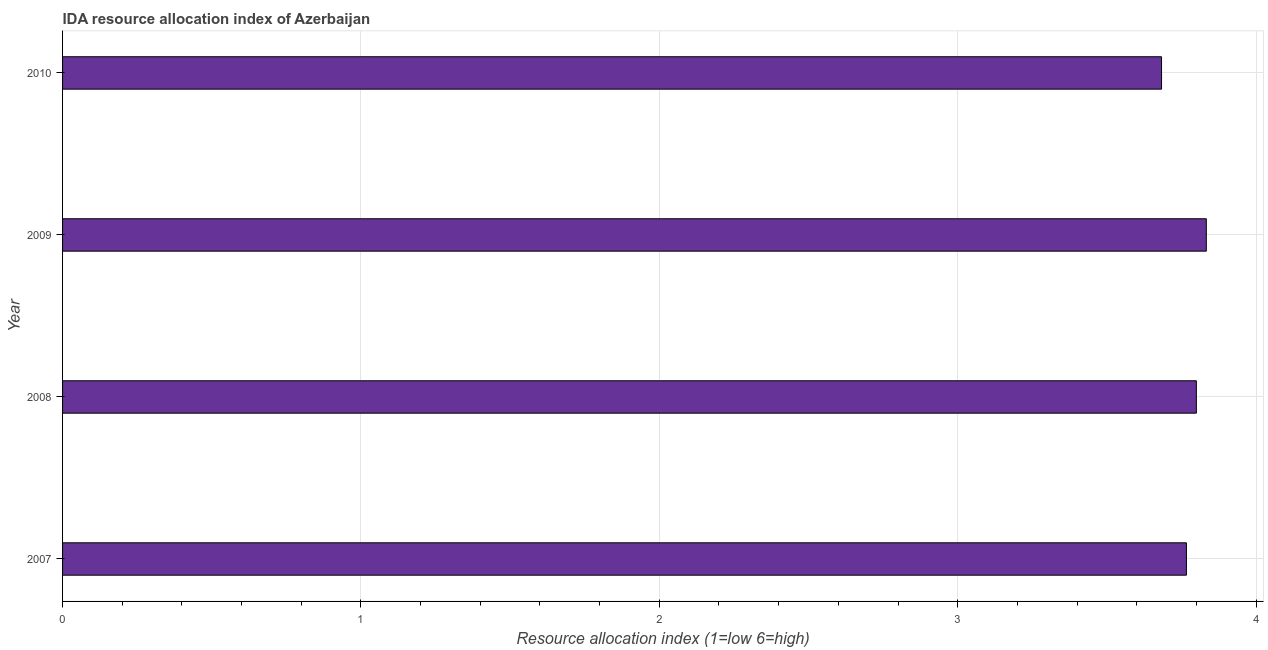Does the graph contain any zero values?
Make the answer very short. No. Does the graph contain grids?
Provide a succinct answer. Yes. What is the title of the graph?
Keep it short and to the point. IDA resource allocation index of Azerbaijan. What is the label or title of the X-axis?
Make the answer very short. Resource allocation index (1=low 6=high). What is the label or title of the Y-axis?
Make the answer very short. Year. What is the ida resource allocation index in 2007?
Offer a very short reply. 3.77. Across all years, what is the maximum ida resource allocation index?
Offer a terse response. 3.83. Across all years, what is the minimum ida resource allocation index?
Make the answer very short. 3.68. What is the sum of the ida resource allocation index?
Offer a terse response. 15.08. What is the average ida resource allocation index per year?
Your answer should be compact. 3.77. What is the median ida resource allocation index?
Your answer should be compact. 3.78. Do a majority of the years between 2008 and 2007 (inclusive) have ida resource allocation index greater than 3.8 ?
Give a very brief answer. No. What is the difference between the highest and the second highest ida resource allocation index?
Your response must be concise. 0.03. In how many years, is the ida resource allocation index greater than the average ida resource allocation index taken over all years?
Offer a terse response. 2. How many bars are there?
Make the answer very short. 4. Are all the bars in the graph horizontal?
Provide a short and direct response. Yes. Are the values on the major ticks of X-axis written in scientific E-notation?
Make the answer very short. No. What is the Resource allocation index (1=low 6=high) of 2007?
Your answer should be very brief. 3.77. What is the Resource allocation index (1=low 6=high) in 2009?
Offer a terse response. 3.83. What is the Resource allocation index (1=low 6=high) of 2010?
Keep it short and to the point. 3.68. What is the difference between the Resource allocation index (1=low 6=high) in 2007 and 2008?
Offer a terse response. -0.03. What is the difference between the Resource allocation index (1=low 6=high) in 2007 and 2009?
Your response must be concise. -0.07. What is the difference between the Resource allocation index (1=low 6=high) in 2007 and 2010?
Give a very brief answer. 0.08. What is the difference between the Resource allocation index (1=low 6=high) in 2008 and 2009?
Your answer should be very brief. -0.03. What is the difference between the Resource allocation index (1=low 6=high) in 2008 and 2010?
Offer a terse response. 0.12. What is the difference between the Resource allocation index (1=low 6=high) in 2009 and 2010?
Offer a very short reply. 0.15. What is the ratio of the Resource allocation index (1=low 6=high) in 2008 to that in 2009?
Offer a terse response. 0.99. What is the ratio of the Resource allocation index (1=low 6=high) in 2008 to that in 2010?
Keep it short and to the point. 1.03. What is the ratio of the Resource allocation index (1=low 6=high) in 2009 to that in 2010?
Give a very brief answer. 1.04. 